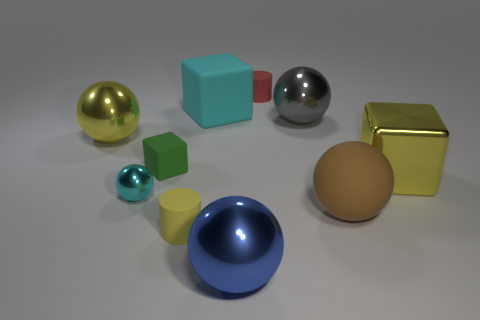Is there a tiny ball? yes 